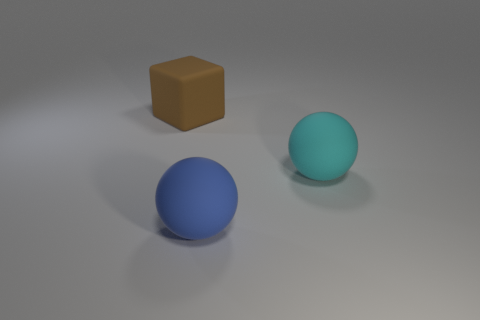Do the blue thing and the big thing that is right of the large blue object have the same shape?
Your answer should be very brief. Yes. What number of blue metal cylinders have the same size as the cyan rubber sphere?
Keep it short and to the point. 0. There is a rubber thing that is right of the large blue sphere; does it have the same shape as the blue object left of the cyan thing?
Make the answer very short. Yes. The big object that is on the left side of the large matte ball in front of the large cyan rubber sphere is what color?
Your answer should be compact. Brown. What color is the other large object that is the same shape as the big cyan matte object?
Your answer should be very brief. Blue. What is the size of the other object that is the same shape as the big blue object?
Offer a terse response. Large. Is the number of large blue spheres in front of the matte cube less than the number of big cyan spheres?
Provide a short and direct response. No. The large matte thing that is behind the big thing to the right of the blue matte object is what shape?
Give a very brief answer. Cube. The matte cube is what color?
Your response must be concise. Brown. How many other objects are the same size as the blue sphere?
Your response must be concise. 2. 